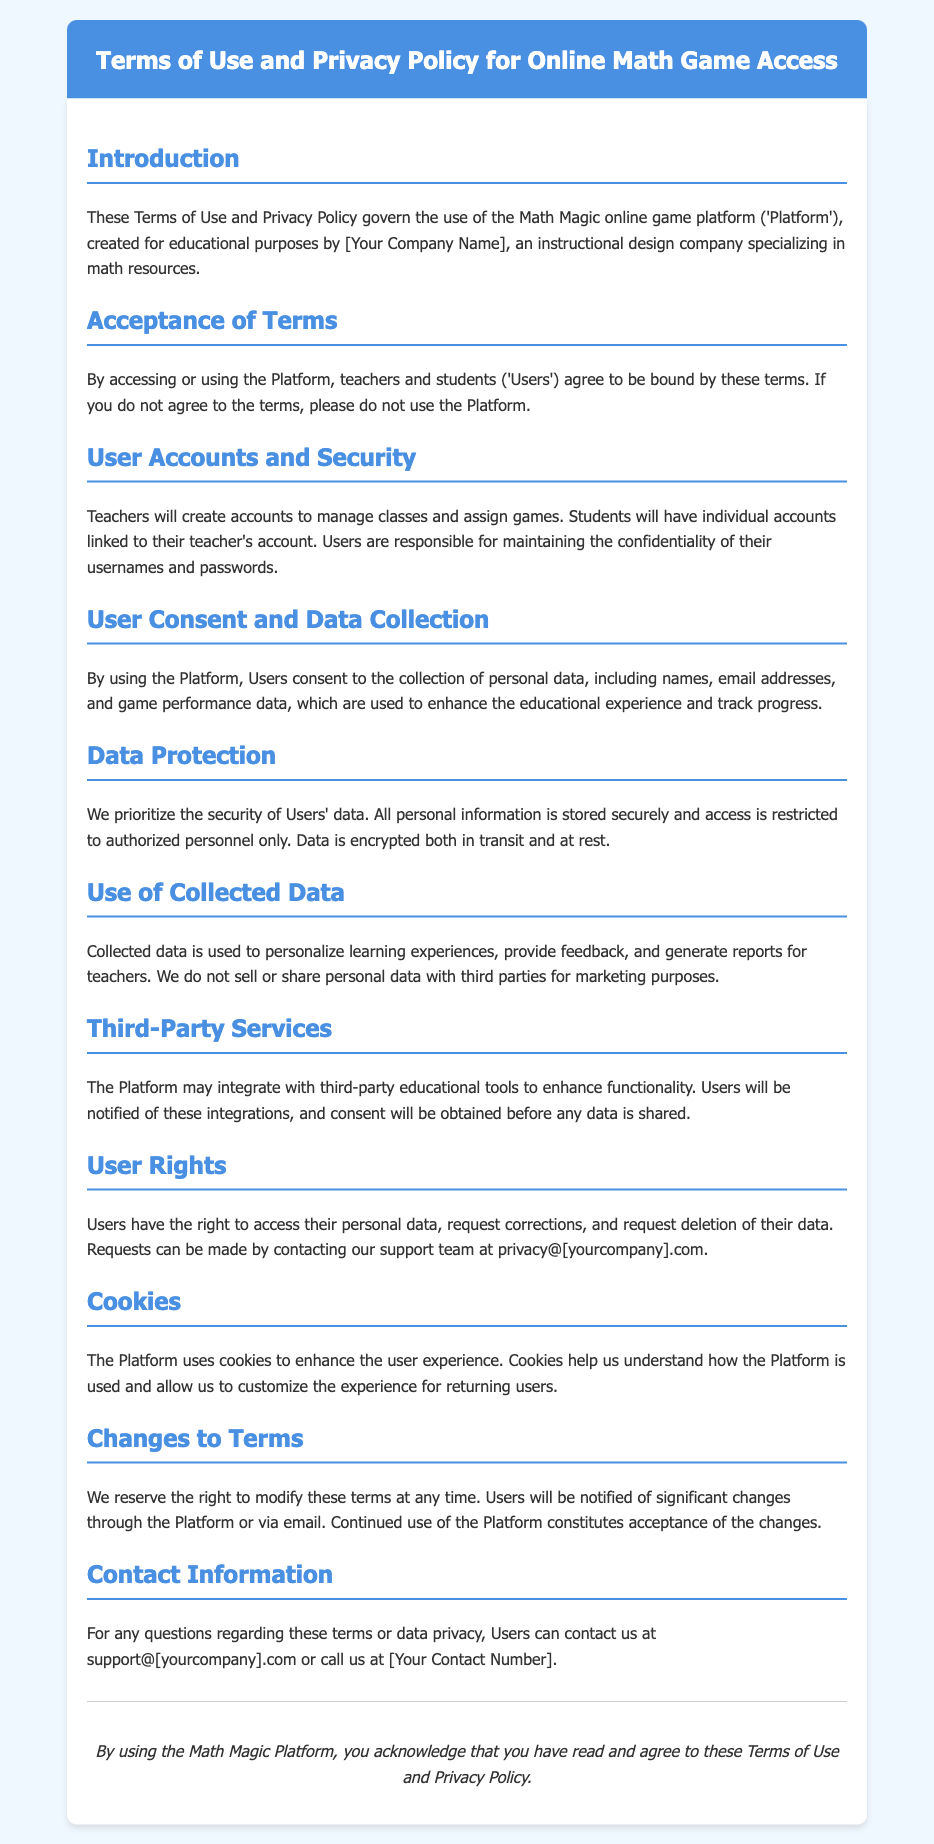What is the name of the platform? The document introduces the platform as "Math Magic online game platform".
Answer: Math Magic Who created the platform? The document states that the platform was created by "[Your Company Name]".
Answer: [Your Company Name] What types of personal data are collected? The document mentions "names, email addresses, and game performance data" as the types of personal data collected.
Answer: names, email addresses, and game performance data Who can users contact for privacy-related requests? The document provides an email for contacting privacy-related requests as "privacy@[yourcompany].com".
Answer: privacy@[yourcompany].com What is the purpose of using collected data? The document states that collected data is used "to personalize learning experiences, provide feedback, and generate reports for teachers".
Answer: to personalize learning experiences, provide feedback, and generate reports for teachers What encryption methods are mentioned for data security? The document specifies that "Data is encrypted both in transit and at rest".
Answer: in transit and at rest What can users request regarding their personal data? The document mentions users have the right "to access their personal data, request corrections, and request deletion of their data".
Answer: access, corrections, and deletion What is stated about third-party data sharing? The document states, "We do not sell or share personal data with third parties for marketing purposes".
Answer: do not sell or share What should users do if they do not agree with the terms? The document advises users, "If you do not agree to the terms, please do not use the Platform".
Answer: do not use the Platform 